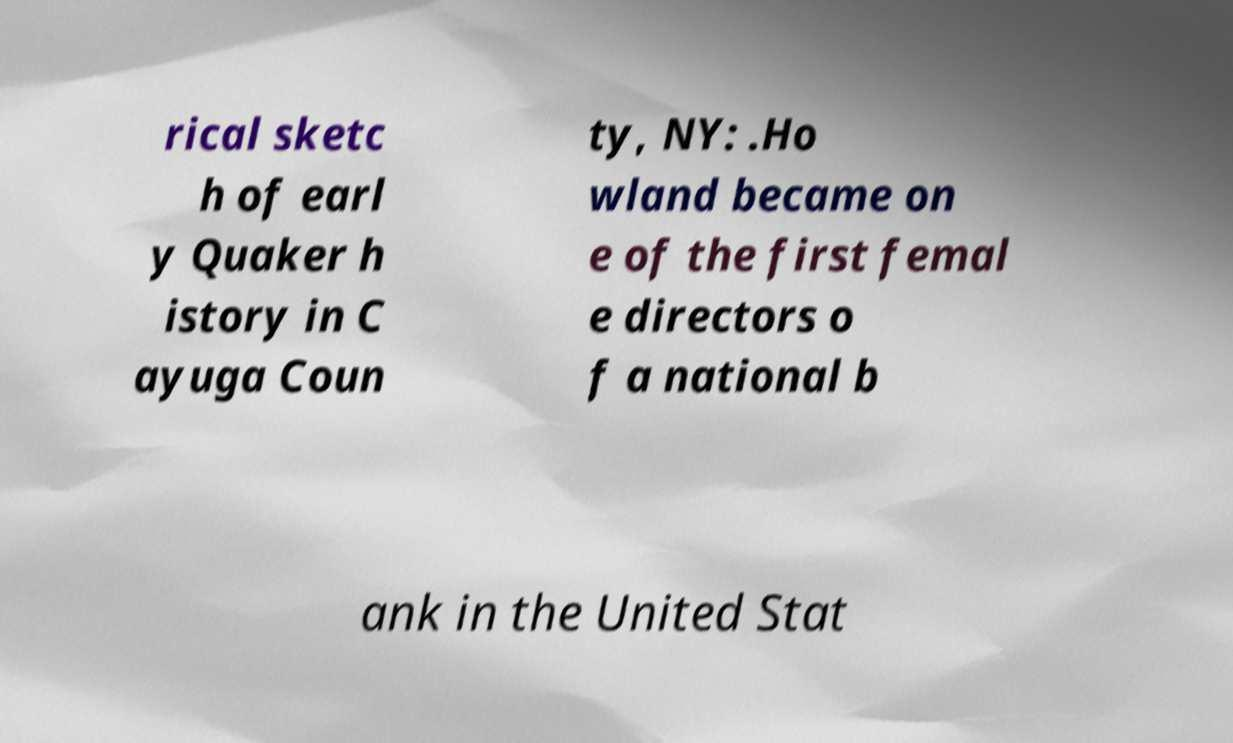I need the written content from this picture converted into text. Can you do that? rical sketc h of earl y Quaker h istory in C ayuga Coun ty, NY: .Ho wland became on e of the first femal e directors o f a national b ank in the United Stat 